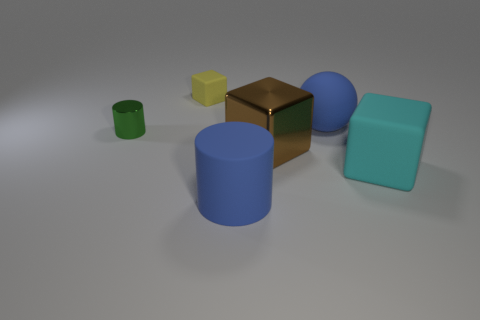How many matte things are either big blue objects or blue spheres? In the image, there is one large blue cylinder and two blue spheres. All objects appear to have a matte finish. Therefore, there are three matte things that are either big blue objects or blue spheres. 